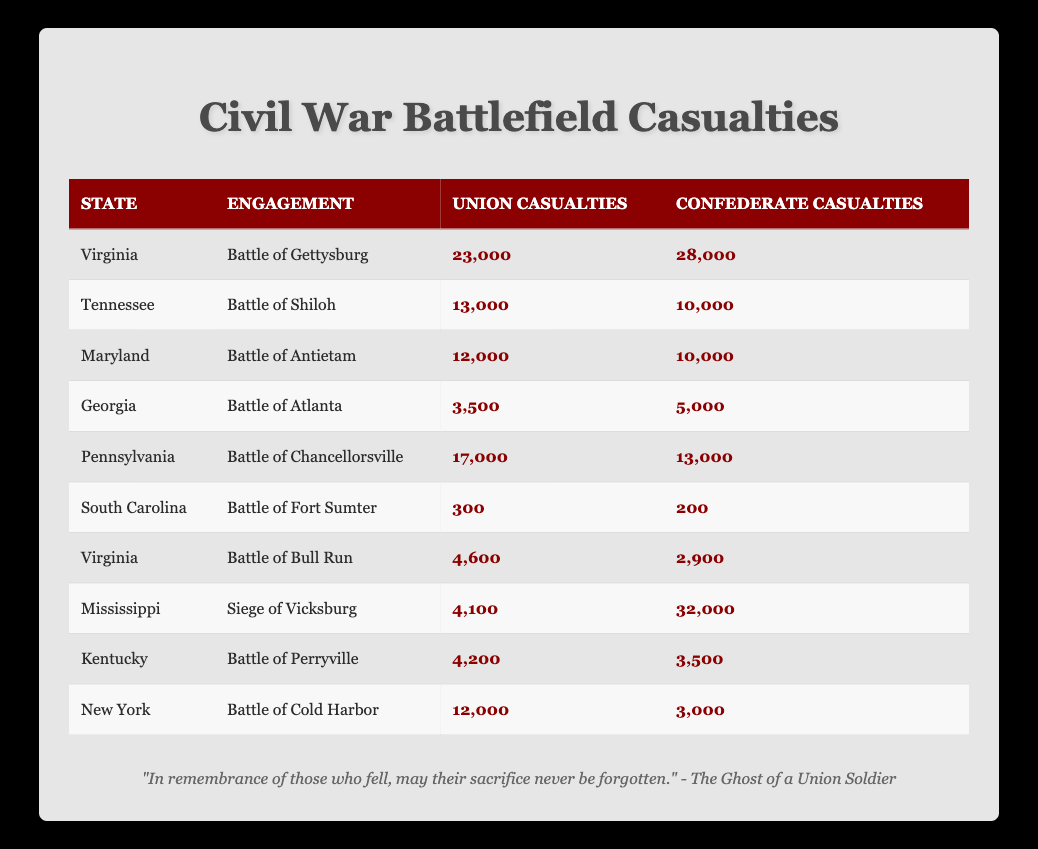What are the Union casualties in the Battle of Gettysburg? By referring to the table, the row for the Battle of Gettysburg indicates the Union casualties as 23,000.
Answer: 23,000 Which engagement had the highest Confederate casualties? Looking through the casualties for each engagement, the Siege of Vicksburg shows the highest Confederate casualties at 32,000.
Answer: 32,000 What is the total number of Union casualties across all engagements listed? Summing the Union casualties: 23,000 (Gettysburg) + 13,000 (Shiloh) + 12,000 (Antietam) + 3,500 (Atlanta) + 17,000 (Chancellorsville) + 300 (Fort Sumter) + 4,600 (Bull Run) + 4,100 (Vicksburg) + 4,200 (Perryville) + 12,000 (Cold Harbor) =  91,700.
Answer: 91,700 Did the Union suffer more casualties than the Confederates in the Battle of Chancellorsville? Comparing the casualties in Chancellorsville, the Union had 17,000 and the Confederates had 13,000; since 17,000 > 13,000, the Union did suffer more casualties.
Answer: Yes What is the difference in casualties between the Union and Confederates in the Battle of Shiloh? In the Battle of Shiloh, the Union suffered 13,000 casualties and the Confederates suffered 10,000 casualties. The difference is 13,000 - 10,000 = 3,000.
Answer: 3,000 What state had the highest total casualties (Union plus Confederate) in the provided battles? Calculating total casualties for each state: Virginia (23,000 + 28,000 = 51,000), Tennessee (13,000 + 10,000 = 23,000), Maryland (12,000 + 10,000 = 22,000), Georgia (3,500 + 5,000 = 8,500), Pennsylvania (17,000 + 13,000 = 30,000), South Carolina (300 + 200 = 500), Mississippi (4,100 + 32,000 = 36,100), Kentucky (4,200 + 3,500 = 7,700), New York (12,000 + 3,000 = 15,000). The highest total is Virginia with 51,000 casualties.
Answer: Virginia What percentage of Union casualties occurred in the Battle of Gettysburg compared to all Union casualties? The total Union casualties calculated previously are 91,700. The Union casualties in Gettysburg are 23,000. The percentage is (23,000 / 91,700) * 100 ≈ 25.10%.
Answer: Approximately 25.10% Which battle had the least number of casualties overall? By reviewing the total casualties for each battle, the Battle of Fort Sumter had the least total casualties: 300 (Union) + 200 (Confederate) = 500.
Answer: Battle of Fort Sumter In which engagement did the Confederate casualties significantly outnumber the Union casualties? In the Siege of Vicksburg, Confederate casualties are 32,000, while Union casualties are only 4,100, indicating a significant disparity.
Answer: Siege of Vicksburg Was the total number of Confederate casualties across all battles greater than 100,000? Adding Confederate casualties: 28,000 (Gettysburg) + 10,000 (Shiloh) + 10,000 (Antietam) + 5,000 (Atlanta) + 13,000 (Chancellorsville) + 200 (Fort Sumter) + 2,900 (Bull Run) + 32,000 (Vicksburg) + 3,500 (Perryville) + 3,000 (Cold Harbor) = 105,600. Since 105,600 > 100,000, the answer is yes.
Answer: Yes 